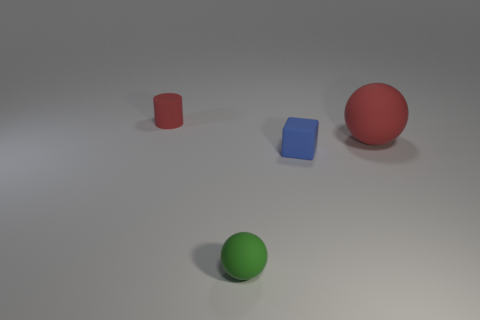How many cylinders are either blue matte things or large gray objects?
Your answer should be compact. 0. What is the color of the rubber cube that is the same size as the rubber cylinder?
Your answer should be very brief. Blue. How many rubber things are both behind the blue object and right of the green ball?
Your answer should be compact. 1. What is the material of the red ball?
Keep it short and to the point. Rubber. What number of things are either tiny blue matte cubes or green spheres?
Your response must be concise. 2. Is the size of the sphere behind the tiny matte sphere the same as the green matte sphere that is in front of the block?
Give a very brief answer. No. How many other objects are there of the same size as the blue thing?
Provide a short and direct response. 2. How many objects are either tiny rubber things to the right of the small red matte thing or objects left of the large red ball?
Your answer should be compact. 3. Does the small green object have the same material as the tiny thing that is behind the large red rubber object?
Your answer should be very brief. Yes. How many other things are there of the same shape as the tiny red object?
Your response must be concise. 0. 